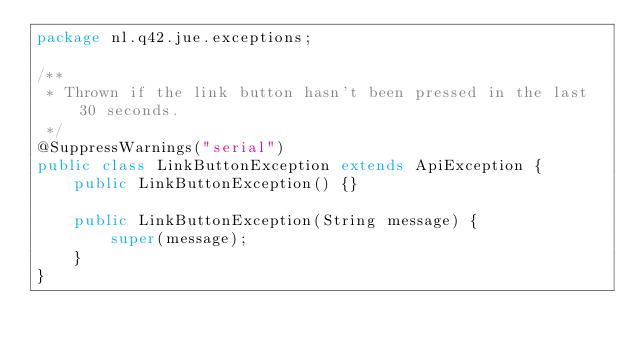Convert code to text. <code><loc_0><loc_0><loc_500><loc_500><_Java_>package nl.q42.jue.exceptions;

/**
 * Thrown if the link button hasn't been pressed in the last 30 seconds.
 */
@SuppressWarnings("serial")
public class LinkButtonException extends ApiException {
	public LinkButtonException() {}
	
	public LinkButtonException(String message) {
		super(message);
	}
}
</code> 